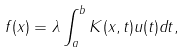Convert formula to latex. <formula><loc_0><loc_0><loc_500><loc_500>f ( x ) = \lambda \int _ { a } ^ { b } K ( x , t ) u ( t ) d t ,</formula> 